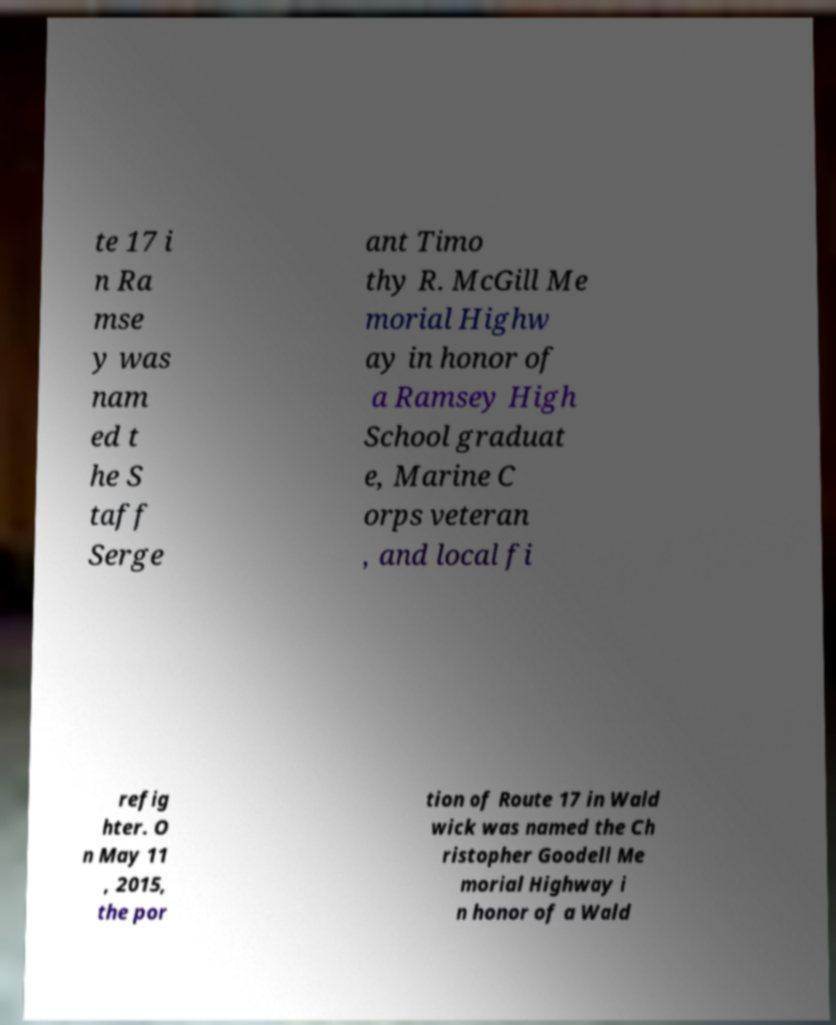Can you accurately transcribe the text from the provided image for me? te 17 i n Ra mse y was nam ed t he S taff Serge ant Timo thy R. McGill Me morial Highw ay in honor of a Ramsey High School graduat e, Marine C orps veteran , and local fi refig hter. O n May 11 , 2015, the por tion of Route 17 in Wald wick was named the Ch ristopher Goodell Me morial Highway i n honor of a Wald 